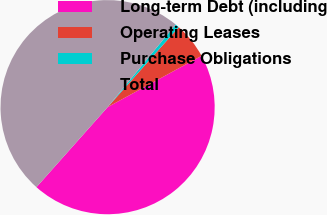Convert chart to OTSL. <chart><loc_0><loc_0><loc_500><loc_500><pie_chart><fcel>Long-term Debt (including<fcel>Operating Leases<fcel>Purchase Obligations<fcel>Total<nl><fcel>44.53%<fcel>5.47%<fcel>0.61%<fcel>49.39%<nl></chart> 